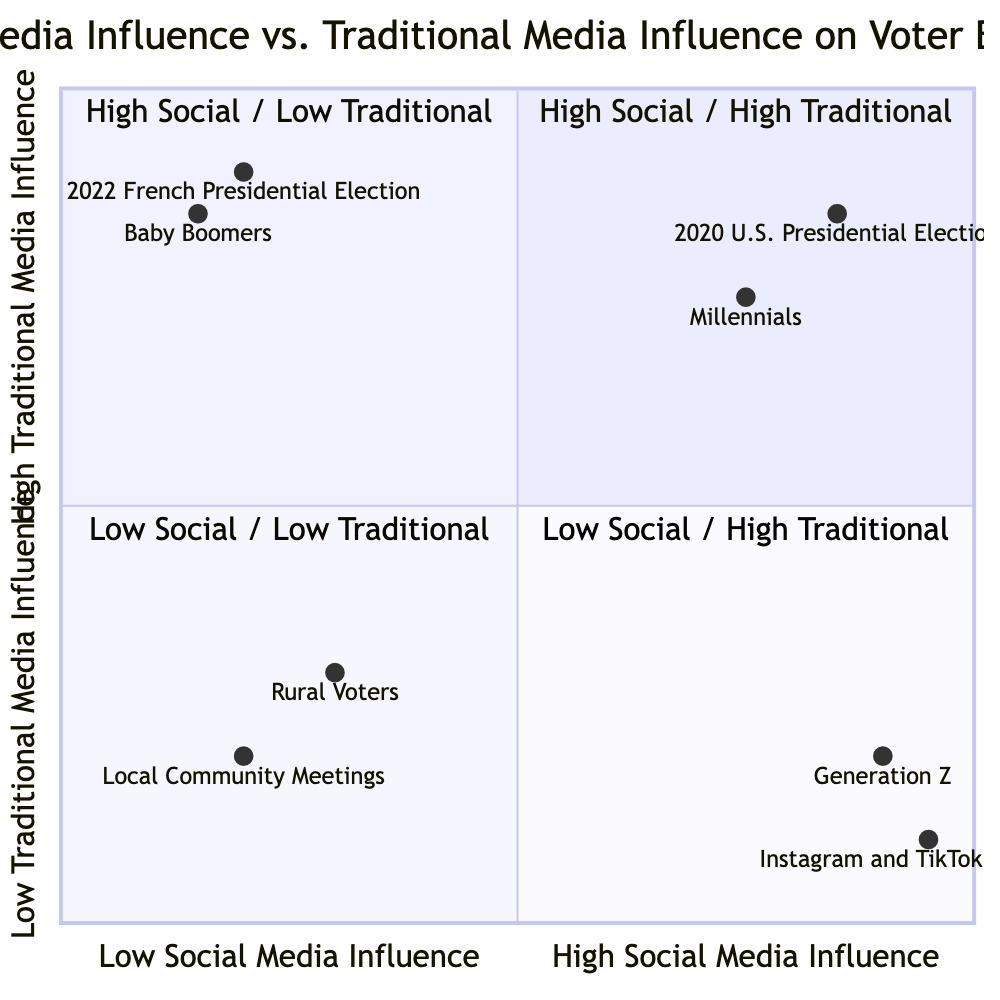What demographic is associated with high social and traditional media influence? The quadrant for high social media and high traditional media shows both Millennials and the 2020 U.S. Presidential Election, with Millennials being a demographic closely linked to this area.
Answer: Millennials Which social media platforms are highlighted as influencers in voter behavior? The quadrant for high social media and low traditional media identifies Instagram and TikTok as significant platforms affecting voter behavior.
Answer: Instagram and TikTok Influences How many entities are located in the high social and low traditional media quadrant? The high social and low traditional media quadrant includes two entities: Generation Z and Instagram and TikTok Influences. Therefore, the total count is two.
Answer: 2 Which demographic primarily relies on traditional media for political news? The quadrant for low social media and high traditional media features Baby Boomers, indicating this demographic's preference for traditional media outlets.
Answer: Baby Boomers What is the influence of local community meetings on rural voters? The quadrant for low social media and low traditional media shows Rural Voters with Local Community Meetings being a major source of information, indicating that rural voters primarily engage with local gatherings rather than broader media.
Answer: Local Community Meetings 